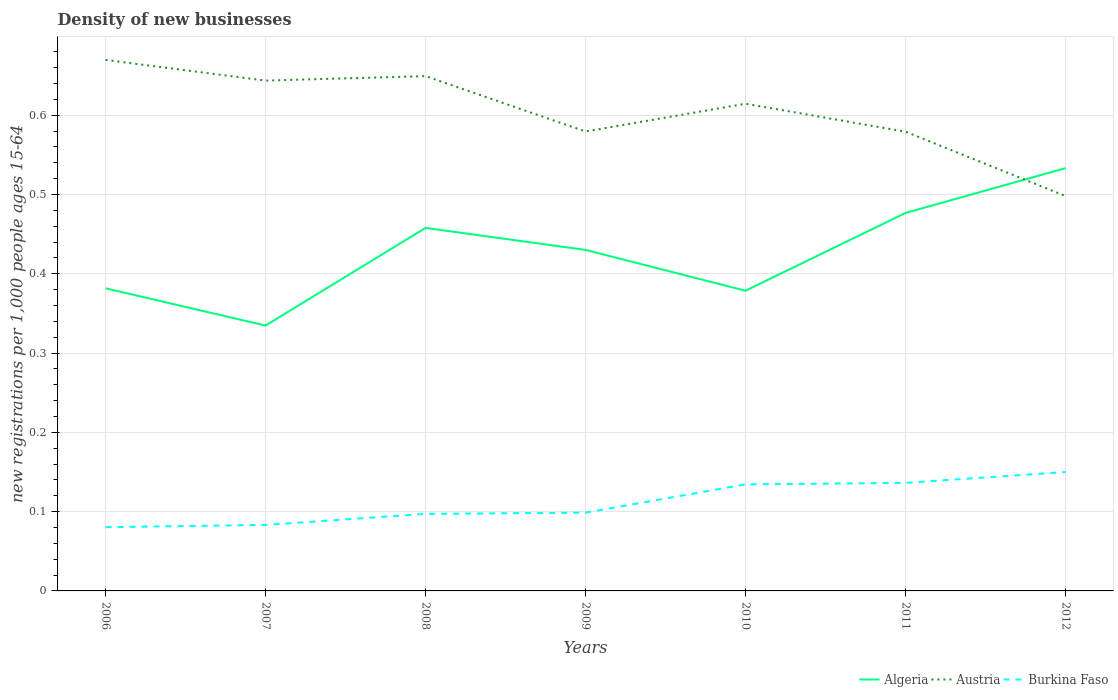Does the line corresponding to Algeria intersect with the line corresponding to Austria?
Your response must be concise. Yes. Is the number of lines equal to the number of legend labels?
Offer a very short reply. Yes. Across all years, what is the maximum number of new registrations in Burkina Faso?
Offer a very short reply. 0.08. In which year was the number of new registrations in Burkina Faso maximum?
Make the answer very short. 2006. What is the total number of new registrations in Austria in the graph?
Give a very brief answer. 0.07. What is the difference between the highest and the second highest number of new registrations in Austria?
Offer a terse response. 0.17. Is the number of new registrations in Burkina Faso strictly greater than the number of new registrations in Algeria over the years?
Your answer should be compact. Yes. Are the values on the major ticks of Y-axis written in scientific E-notation?
Ensure brevity in your answer.  No. Does the graph contain any zero values?
Keep it short and to the point. No. Where does the legend appear in the graph?
Offer a very short reply. Bottom right. How are the legend labels stacked?
Your answer should be compact. Horizontal. What is the title of the graph?
Offer a very short reply. Density of new businesses. Does "Kuwait" appear as one of the legend labels in the graph?
Your answer should be compact. No. What is the label or title of the X-axis?
Give a very brief answer. Years. What is the label or title of the Y-axis?
Keep it short and to the point. New registrations per 1,0 people ages 15-64. What is the new registrations per 1,000 people ages 15-64 in Algeria in 2006?
Your answer should be compact. 0.38. What is the new registrations per 1,000 people ages 15-64 in Austria in 2006?
Offer a very short reply. 0.67. What is the new registrations per 1,000 people ages 15-64 in Burkina Faso in 2006?
Provide a succinct answer. 0.08. What is the new registrations per 1,000 people ages 15-64 of Algeria in 2007?
Ensure brevity in your answer.  0.33. What is the new registrations per 1,000 people ages 15-64 in Austria in 2007?
Your answer should be compact. 0.64. What is the new registrations per 1,000 people ages 15-64 in Burkina Faso in 2007?
Your response must be concise. 0.08. What is the new registrations per 1,000 people ages 15-64 in Algeria in 2008?
Your response must be concise. 0.46. What is the new registrations per 1,000 people ages 15-64 in Austria in 2008?
Keep it short and to the point. 0.65. What is the new registrations per 1,000 people ages 15-64 in Burkina Faso in 2008?
Provide a succinct answer. 0.1. What is the new registrations per 1,000 people ages 15-64 of Algeria in 2009?
Your answer should be very brief. 0.43. What is the new registrations per 1,000 people ages 15-64 of Austria in 2009?
Your answer should be very brief. 0.58. What is the new registrations per 1,000 people ages 15-64 in Burkina Faso in 2009?
Ensure brevity in your answer.  0.1. What is the new registrations per 1,000 people ages 15-64 in Algeria in 2010?
Offer a very short reply. 0.38. What is the new registrations per 1,000 people ages 15-64 of Austria in 2010?
Your response must be concise. 0.61. What is the new registrations per 1,000 people ages 15-64 of Burkina Faso in 2010?
Give a very brief answer. 0.13. What is the new registrations per 1,000 people ages 15-64 in Algeria in 2011?
Offer a very short reply. 0.48. What is the new registrations per 1,000 people ages 15-64 in Austria in 2011?
Make the answer very short. 0.58. What is the new registrations per 1,000 people ages 15-64 in Burkina Faso in 2011?
Your answer should be very brief. 0.14. What is the new registrations per 1,000 people ages 15-64 in Algeria in 2012?
Your answer should be compact. 0.53. What is the new registrations per 1,000 people ages 15-64 in Austria in 2012?
Give a very brief answer. 0.5. What is the new registrations per 1,000 people ages 15-64 of Burkina Faso in 2012?
Your response must be concise. 0.15. Across all years, what is the maximum new registrations per 1,000 people ages 15-64 in Algeria?
Your answer should be very brief. 0.53. Across all years, what is the maximum new registrations per 1,000 people ages 15-64 of Austria?
Offer a very short reply. 0.67. Across all years, what is the maximum new registrations per 1,000 people ages 15-64 in Burkina Faso?
Make the answer very short. 0.15. Across all years, what is the minimum new registrations per 1,000 people ages 15-64 of Algeria?
Offer a very short reply. 0.33. Across all years, what is the minimum new registrations per 1,000 people ages 15-64 in Austria?
Offer a very short reply. 0.5. Across all years, what is the minimum new registrations per 1,000 people ages 15-64 of Burkina Faso?
Ensure brevity in your answer.  0.08. What is the total new registrations per 1,000 people ages 15-64 of Algeria in the graph?
Ensure brevity in your answer.  2.99. What is the total new registrations per 1,000 people ages 15-64 in Austria in the graph?
Provide a succinct answer. 4.23. What is the total new registrations per 1,000 people ages 15-64 of Burkina Faso in the graph?
Offer a terse response. 0.78. What is the difference between the new registrations per 1,000 people ages 15-64 of Algeria in 2006 and that in 2007?
Offer a terse response. 0.05. What is the difference between the new registrations per 1,000 people ages 15-64 in Austria in 2006 and that in 2007?
Provide a short and direct response. 0.03. What is the difference between the new registrations per 1,000 people ages 15-64 in Burkina Faso in 2006 and that in 2007?
Offer a very short reply. -0. What is the difference between the new registrations per 1,000 people ages 15-64 in Algeria in 2006 and that in 2008?
Offer a terse response. -0.08. What is the difference between the new registrations per 1,000 people ages 15-64 of Austria in 2006 and that in 2008?
Give a very brief answer. 0.02. What is the difference between the new registrations per 1,000 people ages 15-64 in Burkina Faso in 2006 and that in 2008?
Ensure brevity in your answer.  -0.02. What is the difference between the new registrations per 1,000 people ages 15-64 of Algeria in 2006 and that in 2009?
Your answer should be very brief. -0.05. What is the difference between the new registrations per 1,000 people ages 15-64 of Austria in 2006 and that in 2009?
Make the answer very short. 0.09. What is the difference between the new registrations per 1,000 people ages 15-64 in Burkina Faso in 2006 and that in 2009?
Keep it short and to the point. -0.02. What is the difference between the new registrations per 1,000 people ages 15-64 of Algeria in 2006 and that in 2010?
Provide a short and direct response. 0. What is the difference between the new registrations per 1,000 people ages 15-64 of Austria in 2006 and that in 2010?
Your answer should be compact. 0.06. What is the difference between the new registrations per 1,000 people ages 15-64 of Burkina Faso in 2006 and that in 2010?
Provide a succinct answer. -0.05. What is the difference between the new registrations per 1,000 people ages 15-64 of Algeria in 2006 and that in 2011?
Give a very brief answer. -0.1. What is the difference between the new registrations per 1,000 people ages 15-64 in Austria in 2006 and that in 2011?
Make the answer very short. 0.09. What is the difference between the new registrations per 1,000 people ages 15-64 of Burkina Faso in 2006 and that in 2011?
Offer a very short reply. -0.06. What is the difference between the new registrations per 1,000 people ages 15-64 in Algeria in 2006 and that in 2012?
Ensure brevity in your answer.  -0.15. What is the difference between the new registrations per 1,000 people ages 15-64 of Austria in 2006 and that in 2012?
Provide a short and direct response. 0.17. What is the difference between the new registrations per 1,000 people ages 15-64 in Burkina Faso in 2006 and that in 2012?
Ensure brevity in your answer.  -0.07. What is the difference between the new registrations per 1,000 people ages 15-64 in Algeria in 2007 and that in 2008?
Your answer should be compact. -0.12. What is the difference between the new registrations per 1,000 people ages 15-64 of Austria in 2007 and that in 2008?
Your answer should be very brief. -0.01. What is the difference between the new registrations per 1,000 people ages 15-64 of Burkina Faso in 2007 and that in 2008?
Keep it short and to the point. -0.01. What is the difference between the new registrations per 1,000 people ages 15-64 in Algeria in 2007 and that in 2009?
Make the answer very short. -0.1. What is the difference between the new registrations per 1,000 people ages 15-64 in Austria in 2007 and that in 2009?
Offer a terse response. 0.06. What is the difference between the new registrations per 1,000 people ages 15-64 in Burkina Faso in 2007 and that in 2009?
Your answer should be compact. -0.02. What is the difference between the new registrations per 1,000 people ages 15-64 in Algeria in 2007 and that in 2010?
Ensure brevity in your answer.  -0.04. What is the difference between the new registrations per 1,000 people ages 15-64 in Austria in 2007 and that in 2010?
Your response must be concise. 0.03. What is the difference between the new registrations per 1,000 people ages 15-64 of Burkina Faso in 2007 and that in 2010?
Your answer should be compact. -0.05. What is the difference between the new registrations per 1,000 people ages 15-64 in Algeria in 2007 and that in 2011?
Keep it short and to the point. -0.14. What is the difference between the new registrations per 1,000 people ages 15-64 of Austria in 2007 and that in 2011?
Your answer should be compact. 0.06. What is the difference between the new registrations per 1,000 people ages 15-64 in Burkina Faso in 2007 and that in 2011?
Make the answer very short. -0.05. What is the difference between the new registrations per 1,000 people ages 15-64 of Algeria in 2007 and that in 2012?
Give a very brief answer. -0.2. What is the difference between the new registrations per 1,000 people ages 15-64 in Austria in 2007 and that in 2012?
Your answer should be compact. 0.15. What is the difference between the new registrations per 1,000 people ages 15-64 of Burkina Faso in 2007 and that in 2012?
Offer a terse response. -0.07. What is the difference between the new registrations per 1,000 people ages 15-64 in Algeria in 2008 and that in 2009?
Offer a terse response. 0.03. What is the difference between the new registrations per 1,000 people ages 15-64 in Austria in 2008 and that in 2009?
Keep it short and to the point. 0.07. What is the difference between the new registrations per 1,000 people ages 15-64 in Burkina Faso in 2008 and that in 2009?
Give a very brief answer. -0. What is the difference between the new registrations per 1,000 people ages 15-64 of Algeria in 2008 and that in 2010?
Your response must be concise. 0.08. What is the difference between the new registrations per 1,000 people ages 15-64 of Austria in 2008 and that in 2010?
Provide a succinct answer. 0.03. What is the difference between the new registrations per 1,000 people ages 15-64 in Burkina Faso in 2008 and that in 2010?
Provide a short and direct response. -0.04. What is the difference between the new registrations per 1,000 people ages 15-64 of Algeria in 2008 and that in 2011?
Your answer should be compact. -0.02. What is the difference between the new registrations per 1,000 people ages 15-64 of Austria in 2008 and that in 2011?
Provide a short and direct response. 0.07. What is the difference between the new registrations per 1,000 people ages 15-64 of Burkina Faso in 2008 and that in 2011?
Ensure brevity in your answer.  -0.04. What is the difference between the new registrations per 1,000 people ages 15-64 in Algeria in 2008 and that in 2012?
Your answer should be very brief. -0.08. What is the difference between the new registrations per 1,000 people ages 15-64 of Austria in 2008 and that in 2012?
Give a very brief answer. 0.15. What is the difference between the new registrations per 1,000 people ages 15-64 of Burkina Faso in 2008 and that in 2012?
Provide a short and direct response. -0.05. What is the difference between the new registrations per 1,000 people ages 15-64 in Algeria in 2009 and that in 2010?
Provide a short and direct response. 0.05. What is the difference between the new registrations per 1,000 people ages 15-64 in Austria in 2009 and that in 2010?
Your response must be concise. -0.04. What is the difference between the new registrations per 1,000 people ages 15-64 in Burkina Faso in 2009 and that in 2010?
Your answer should be very brief. -0.04. What is the difference between the new registrations per 1,000 people ages 15-64 in Algeria in 2009 and that in 2011?
Your answer should be very brief. -0.05. What is the difference between the new registrations per 1,000 people ages 15-64 in Burkina Faso in 2009 and that in 2011?
Your response must be concise. -0.04. What is the difference between the new registrations per 1,000 people ages 15-64 in Algeria in 2009 and that in 2012?
Your answer should be compact. -0.1. What is the difference between the new registrations per 1,000 people ages 15-64 of Austria in 2009 and that in 2012?
Your response must be concise. 0.08. What is the difference between the new registrations per 1,000 people ages 15-64 of Burkina Faso in 2009 and that in 2012?
Offer a terse response. -0.05. What is the difference between the new registrations per 1,000 people ages 15-64 in Algeria in 2010 and that in 2011?
Provide a short and direct response. -0.1. What is the difference between the new registrations per 1,000 people ages 15-64 in Austria in 2010 and that in 2011?
Offer a very short reply. 0.04. What is the difference between the new registrations per 1,000 people ages 15-64 of Burkina Faso in 2010 and that in 2011?
Provide a short and direct response. -0. What is the difference between the new registrations per 1,000 people ages 15-64 in Algeria in 2010 and that in 2012?
Offer a very short reply. -0.15. What is the difference between the new registrations per 1,000 people ages 15-64 in Austria in 2010 and that in 2012?
Keep it short and to the point. 0.12. What is the difference between the new registrations per 1,000 people ages 15-64 in Burkina Faso in 2010 and that in 2012?
Provide a short and direct response. -0.02. What is the difference between the new registrations per 1,000 people ages 15-64 in Algeria in 2011 and that in 2012?
Make the answer very short. -0.06. What is the difference between the new registrations per 1,000 people ages 15-64 of Austria in 2011 and that in 2012?
Your answer should be compact. 0.08. What is the difference between the new registrations per 1,000 people ages 15-64 in Burkina Faso in 2011 and that in 2012?
Provide a succinct answer. -0.01. What is the difference between the new registrations per 1,000 people ages 15-64 of Algeria in 2006 and the new registrations per 1,000 people ages 15-64 of Austria in 2007?
Provide a short and direct response. -0.26. What is the difference between the new registrations per 1,000 people ages 15-64 in Algeria in 2006 and the new registrations per 1,000 people ages 15-64 in Burkina Faso in 2007?
Your answer should be compact. 0.3. What is the difference between the new registrations per 1,000 people ages 15-64 in Austria in 2006 and the new registrations per 1,000 people ages 15-64 in Burkina Faso in 2007?
Ensure brevity in your answer.  0.59. What is the difference between the new registrations per 1,000 people ages 15-64 of Algeria in 2006 and the new registrations per 1,000 people ages 15-64 of Austria in 2008?
Provide a succinct answer. -0.27. What is the difference between the new registrations per 1,000 people ages 15-64 in Algeria in 2006 and the new registrations per 1,000 people ages 15-64 in Burkina Faso in 2008?
Ensure brevity in your answer.  0.28. What is the difference between the new registrations per 1,000 people ages 15-64 in Austria in 2006 and the new registrations per 1,000 people ages 15-64 in Burkina Faso in 2008?
Offer a terse response. 0.57. What is the difference between the new registrations per 1,000 people ages 15-64 of Algeria in 2006 and the new registrations per 1,000 people ages 15-64 of Austria in 2009?
Ensure brevity in your answer.  -0.2. What is the difference between the new registrations per 1,000 people ages 15-64 in Algeria in 2006 and the new registrations per 1,000 people ages 15-64 in Burkina Faso in 2009?
Give a very brief answer. 0.28. What is the difference between the new registrations per 1,000 people ages 15-64 of Austria in 2006 and the new registrations per 1,000 people ages 15-64 of Burkina Faso in 2009?
Provide a short and direct response. 0.57. What is the difference between the new registrations per 1,000 people ages 15-64 of Algeria in 2006 and the new registrations per 1,000 people ages 15-64 of Austria in 2010?
Make the answer very short. -0.23. What is the difference between the new registrations per 1,000 people ages 15-64 of Algeria in 2006 and the new registrations per 1,000 people ages 15-64 of Burkina Faso in 2010?
Provide a short and direct response. 0.25. What is the difference between the new registrations per 1,000 people ages 15-64 in Austria in 2006 and the new registrations per 1,000 people ages 15-64 in Burkina Faso in 2010?
Give a very brief answer. 0.54. What is the difference between the new registrations per 1,000 people ages 15-64 in Algeria in 2006 and the new registrations per 1,000 people ages 15-64 in Austria in 2011?
Provide a succinct answer. -0.2. What is the difference between the new registrations per 1,000 people ages 15-64 of Algeria in 2006 and the new registrations per 1,000 people ages 15-64 of Burkina Faso in 2011?
Provide a short and direct response. 0.25. What is the difference between the new registrations per 1,000 people ages 15-64 in Austria in 2006 and the new registrations per 1,000 people ages 15-64 in Burkina Faso in 2011?
Provide a succinct answer. 0.53. What is the difference between the new registrations per 1,000 people ages 15-64 of Algeria in 2006 and the new registrations per 1,000 people ages 15-64 of Austria in 2012?
Give a very brief answer. -0.12. What is the difference between the new registrations per 1,000 people ages 15-64 in Algeria in 2006 and the new registrations per 1,000 people ages 15-64 in Burkina Faso in 2012?
Make the answer very short. 0.23. What is the difference between the new registrations per 1,000 people ages 15-64 in Austria in 2006 and the new registrations per 1,000 people ages 15-64 in Burkina Faso in 2012?
Provide a short and direct response. 0.52. What is the difference between the new registrations per 1,000 people ages 15-64 in Algeria in 2007 and the new registrations per 1,000 people ages 15-64 in Austria in 2008?
Offer a terse response. -0.31. What is the difference between the new registrations per 1,000 people ages 15-64 in Algeria in 2007 and the new registrations per 1,000 people ages 15-64 in Burkina Faso in 2008?
Keep it short and to the point. 0.24. What is the difference between the new registrations per 1,000 people ages 15-64 of Austria in 2007 and the new registrations per 1,000 people ages 15-64 of Burkina Faso in 2008?
Your answer should be very brief. 0.55. What is the difference between the new registrations per 1,000 people ages 15-64 in Algeria in 2007 and the new registrations per 1,000 people ages 15-64 in Austria in 2009?
Your response must be concise. -0.24. What is the difference between the new registrations per 1,000 people ages 15-64 of Algeria in 2007 and the new registrations per 1,000 people ages 15-64 of Burkina Faso in 2009?
Offer a terse response. 0.24. What is the difference between the new registrations per 1,000 people ages 15-64 of Austria in 2007 and the new registrations per 1,000 people ages 15-64 of Burkina Faso in 2009?
Provide a short and direct response. 0.54. What is the difference between the new registrations per 1,000 people ages 15-64 in Algeria in 2007 and the new registrations per 1,000 people ages 15-64 in Austria in 2010?
Provide a short and direct response. -0.28. What is the difference between the new registrations per 1,000 people ages 15-64 in Algeria in 2007 and the new registrations per 1,000 people ages 15-64 in Burkina Faso in 2010?
Keep it short and to the point. 0.2. What is the difference between the new registrations per 1,000 people ages 15-64 of Austria in 2007 and the new registrations per 1,000 people ages 15-64 of Burkina Faso in 2010?
Provide a short and direct response. 0.51. What is the difference between the new registrations per 1,000 people ages 15-64 in Algeria in 2007 and the new registrations per 1,000 people ages 15-64 in Austria in 2011?
Ensure brevity in your answer.  -0.24. What is the difference between the new registrations per 1,000 people ages 15-64 in Algeria in 2007 and the new registrations per 1,000 people ages 15-64 in Burkina Faso in 2011?
Keep it short and to the point. 0.2. What is the difference between the new registrations per 1,000 people ages 15-64 in Austria in 2007 and the new registrations per 1,000 people ages 15-64 in Burkina Faso in 2011?
Provide a succinct answer. 0.51. What is the difference between the new registrations per 1,000 people ages 15-64 of Algeria in 2007 and the new registrations per 1,000 people ages 15-64 of Austria in 2012?
Keep it short and to the point. -0.16. What is the difference between the new registrations per 1,000 people ages 15-64 of Algeria in 2007 and the new registrations per 1,000 people ages 15-64 of Burkina Faso in 2012?
Keep it short and to the point. 0.18. What is the difference between the new registrations per 1,000 people ages 15-64 in Austria in 2007 and the new registrations per 1,000 people ages 15-64 in Burkina Faso in 2012?
Your response must be concise. 0.49. What is the difference between the new registrations per 1,000 people ages 15-64 in Algeria in 2008 and the new registrations per 1,000 people ages 15-64 in Austria in 2009?
Make the answer very short. -0.12. What is the difference between the new registrations per 1,000 people ages 15-64 in Algeria in 2008 and the new registrations per 1,000 people ages 15-64 in Burkina Faso in 2009?
Provide a succinct answer. 0.36. What is the difference between the new registrations per 1,000 people ages 15-64 in Austria in 2008 and the new registrations per 1,000 people ages 15-64 in Burkina Faso in 2009?
Provide a short and direct response. 0.55. What is the difference between the new registrations per 1,000 people ages 15-64 in Algeria in 2008 and the new registrations per 1,000 people ages 15-64 in Austria in 2010?
Ensure brevity in your answer.  -0.16. What is the difference between the new registrations per 1,000 people ages 15-64 in Algeria in 2008 and the new registrations per 1,000 people ages 15-64 in Burkina Faso in 2010?
Your answer should be compact. 0.32. What is the difference between the new registrations per 1,000 people ages 15-64 in Austria in 2008 and the new registrations per 1,000 people ages 15-64 in Burkina Faso in 2010?
Ensure brevity in your answer.  0.52. What is the difference between the new registrations per 1,000 people ages 15-64 of Algeria in 2008 and the new registrations per 1,000 people ages 15-64 of Austria in 2011?
Make the answer very short. -0.12. What is the difference between the new registrations per 1,000 people ages 15-64 in Algeria in 2008 and the new registrations per 1,000 people ages 15-64 in Burkina Faso in 2011?
Ensure brevity in your answer.  0.32. What is the difference between the new registrations per 1,000 people ages 15-64 of Austria in 2008 and the new registrations per 1,000 people ages 15-64 of Burkina Faso in 2011?
Your answer should be very brief. 0.51. What is the difference between the new registrations per 1,000 people ages 15-64 of Algeria in 2008 and the new registrations per 1,000 people ages 15-64 of Austria in 2012?
Ensure brevity in your answer.  -0.04. What is the difference between the new registrations per 1,000 people ages 15-64 of Algeria in 2008 and the new registrations per 1,000 people ages 15-64 of Burkina Faso in 2012?
Offer a terse response. 0.31. What is the difference between the new registrations per 1,000 people ages 15-64 of Austria in 2008 and the new registrations per 1,000 people ages 15-64 of Burkina Faso in 2012?
Your answer should be compact. 0.5. What is the difference between the new registrations per 1,000 people ages 15-64 in Algeria in 2009 and the new registrations per 1,000 people ages 15-64 in Austria in 2010?
Ensure brevity in your answer.  -0.18. What is the difference between the new registrations per 1,000 people ages 15-64 in Algeria in 2009 and the new registrations per 1,000 people ages 15-64 in Burkina Faso in 2010?
Offer a terse response. 0.3. What is the difference between the new registrations per 1,000 people ages 15-64 in Austria in 2009 and the new registrations per 1,000 people ages 15-64 in Burkina Faso in 2010?
Your answer should be very brief. 0.45. What is the difference between the new registrations per 1,000 people ages 15-64 of Algeria in 2009 and the new registrations per 1,000 people ages 15-64 of Austria in 2011?
Your response must be concise. -0.15. What is the difference between the new registrations per 1,000 people ages 15-64 in Algeria in 2009 and the new registrations per 1,000 people ages 15-64 in Burkina Faso in 2011?
Your answer should be compact. 0.29. What is the difference between the new registrations per 1,000 people ages 15-64 in Austria in 2009 and the new registrations per 1,000 people ages 15-64 in Burkina Faso in 2011?
Provide a succinct answer. 0.44. What is the difference between the new registrations per 1,000 people ages 15-64 in Algeria in 2009 and the new registrations per 1,000 people ages 15-64 in Austria in 2012?
Your answer should be very brief. -0.07. What is the difference between the new registrations per 1,000 people ages 15-64 in Algeria in 2009 and the new registrations per 1,000 people ages 15-64 in Burkina Faso in 2012?
Give a very brief answer. 0.28. What is the difference between the new registrations per 1,000 people ages 15-64 of Austria in 2009 and the new registrations per 1,000 people ages 15-64 of Burkina Faso in 2012?
Your response must be concise. 0.43. What is the difference between the new registrations per 1,000 people ages 15-64 in Algeria in 2010 and the new registrations per 1,000 people ages 15-64 in Austria in 2011?
Offer a terse response. -0.2. What is the difference between the new registrations per 1,000 people ages 15-64 of Algeria in 2010 and the new registrations per 1,000 people ages 15-64 of Burkina Faso in 2011?
Offer a terse response. 0.24. What is the difference between the new registrations per 1,000 people ages 15-64 of Austria in 2010 and the new registrations per 1,000 people ages 15-64 of Burkina Faso in 2011?
Your answer should be compact. 0.48. What is the difference between the new registrations per 1,000 people ages 15-64 of Algeria in 2010 and the new registrations per 1,000 people ages 15-64 of Austria in 2012?
Ensure brevity in your answer.  -0.12. What is the difference between the new registrations per 1,000 people ages 15-64 in Algeria in 2010 and the new registrations per 1,000 people ages 15-64 in Burkina Faso in 2012?
Your answer should be very brief. 0.23. What is the difference between the new registrations per 1,000 people ages 15-64 of Austria in 2010 and the new registrations per 1,000 people ages 15-64 of Burkina Faso in 2012?
Your answer should be compact. 0.46. What is the difference between the new registrations per 1,000 people ages 15-64 in Algeria in 2011 and the new registrations per 1,000 people ages 15-64 in Austria in 2012?
Keep it short and to the point. -0.02. What is the difference between the new registrations per 1,000 people ages 15-64 of Algeria in 2011 and the new registrations per 1,000 people ages 15-64 of Burkina Faso in 2012?
Provide a short and direct response. 0.33. What is the difference between the new registrations per 1,000 people ages 15-64 in Austria in 2011 and the new registrations per 1,000 people ages 15-64 in Burkina Faso in 2012?
Offer a very short reply. 0.43. What is the average new registrations per 1,000 people ages 15-64 of Algeria per year?
Provide a succinct answer. 0.43. What is the average new registrations per 1,000 people ages 15-64 of Austria per year?
Your answer should be very brief. 0.6. What is the average new registrations per 1,000 people ages 15-64 of Burkina Faso per year?
Give a very brief answer. 0.11. In the year 2006, what is the difference between the new registrations per 1,000 people ages 15-64 of Algeria and new registrations per 1,000 people ages 15-64 of Austria?
Keep it short and to the point. -0.29. In the year 2006, what is the difference between the new registrations per 1,000 people ages 15-64 of Algeria and new registrations per 1,000 people ages 15-64 of Burkina Faso?
Provide a succinct answer. 0.3. In the year 2006, what is the difference between the new registrations per 1,000 people ages 15-64 of Austria and new registrations per 1,000 people ages 15-64 of Burkina Faso?
Ensure brevity in your answer.  0.59. In the year 2007, what is the difference between the new registrations per 1,000 people ages 15-64 in Algeria and new registrations per 1,000 people ages 15-64 in Austria?
Ensure brevity in your answer.  -0.31. In the year 2007, what is the difference between the new registrations per 1,000 people ages 15-64 of Algeria and new registrations per 1,000 people ages 15-64 of Burkina Faso?
Provide a short and direct response. 0.25. In the year 2007, what is the difference between the new registrations per 1,000 people ages 15-64 of Austria and new registrations per 1,000 people ages 15-64 of Burkina Faso?
Your answer should be compact. 0.56. In the year 2008, what is the difference between the new registrations per 1,000 people ages 15-64 in Algeria and new registrations per 1,000 people ages 15-64 in Austria?
Offer a terse response. -0.19. In the year 2008, what is the difference between the new registrations per 1,000 people ages 15-64 in Algeria and new registrations per 1,000 people ages 15-64 in Burkina Faso?
Ensure brevity in your answer.  0.36. In the year 2008, what is the difference between the new registrations per 1,000 people ages 15-64 of Austria and new registrations per 1,000 people ages 15-64 of Burkina Faso?
Ensure brevity in your answer.  0.55. In the year 2009, what is the difference between the new registrations per 1,000 people ages 15-64 of Algeria and new registrations per 1,000 people ages 15-64 of Austria?
Offer a very short reply. -0.15. In the year 2009, what is the difference between the new registrations per 1,000 people ages 15-64 in Algeria and new registrations per 1,000 people ages 15-64 in Burkina Faso?
Your answer should be very brief. 0.33. In the year 2009, what is the difference between the new registrations per 1,000 people ages 15-64 of Austria and new registrations per 1,000 people ages 15-64 of Burkina Faso?
Give a very brief answer. 0.48. In the year 2010, what is the difference between the new registrations per 1,000 people ages 15-64 of Algeria and new registrations per 1,000 people ages 15-64 of Austria?
Offer a terse response. -0.24. In the year 2010, what is the difference between the new registrations per 1,000 people ages 15-64 of Algeria and new registrations per 1,000 people ages 15-64 of Burkina Faso?
Make the answer very short. 0.24. In the year 2010, what is the difference between the new registrations per 1,000 people ages 15-64 of Austria and new registrations per 1,000 people ages 15-64 of Burkina Faso?
Your response must be concise. 0.48. In the year 2011, what is the difference between the new registrations per 1,000 people ages 15-64 in Algeria and new registrations per 1,000 people ages 15-64 in Austria?
Your response must be concise. -0.1. In the year 2011, what is the difference between the new registrations per 1,000 people ages 15-64 of Algeria and new registrations per 1,000 people ages 15-64 of Burkina Faso?
Your answer should be compact. 0.34. In the year 2011, what is the difference between the new registrations per 1,000 people ages 15-64 of Austria and new registrations per 1,000 people ages 15-64 of Burkina Faso?
Keep it short and to the point. 0.44. In the year 2012, what is the difference between the new registrations per 1,000 people ages 15-64 of Algeria and new registrations per 1,000 people ages 15-64 of Austria?
Give a very brief answer. 0.04. In the year 2012, what is the difference between the new registrations per 1,000 people ages 15-64 in Algeria and new registrations per 1,000 people ages 15-64 in Burkina Faso?
Provide a short and direct response. 0.38. In the year 2012, what is the difference between the new registrations per 1,000 people ages 15-64 in Austria and new registrations per 1,000 people ages 15-64 in Burkina Faso?
Keep it short and to the point. 0.35. What is the ratio of the new registrations per 1,000 people ages 15-64 of Algeria in 2006 to that in 2007?
Ensure brevity in your answer.  1.14. What is the ratio of the new registrations per 1,000 people ages 15-64 of Austria in 2006 to that in 2007?
Provide a succinct answer. 1.04. What is the ratio of the new registrations per 1,000 people ages 15-64 in Burkina Faso in 2006 to that in 2007?
Your answer should be very brief. 0.97. What is the ratio of the new registrations per 1,000 people ages 15-64 of Algeria in 2006 to that in 2008?
Your response must be concise. 0.83. What is the ratio of the new registrations per 1,000 people ages 15-64 of Austria in 2006 to that in 2008?
Provide a short and direct response. 1.03. What is the ratio of the new registrations per 1,000 people ages 15-64 of Burkina Faso in 2006 to that in 2008?
Provide a short and direct response. 0.83. What is the ratio of the new registrations per 1,000 people ages 15-64 in Algeria in 2006 to that in 2009?
Keep it short and to the point. 0.89. What is the ratio of the new registrations per 1,000 people ages 15-64 of Austria in 2006 to that in 2009?
Make the answer very short. 1.16. What is the ratio of the new registrations per 1,000 people ages 15-64 in Burkina Faso in 2006 to that in 2009?
Ensure brevity in your answer.  0.81. What is the ratio of the new registrations per 1,000 people ages 15-64 in Austria in 2006 to that in 2010?
Your response must be concise. 1.09. What is the ratio of the new registrations per 1,000 people ages 15-64 in Burkina Faso in 2006 to that in 2010?
Keep it short and to the point. 0.6. What is the ratio of the new registrations per 1,000 people ages 15-64 of Algeria in 2006 to that in 2011?
Make the answer very short. 0.8. What is the ratio of the new registrations per 1,000 people ages 15-64 of Austria in 2006 to that in 2011?
Provide a succinct answer. 1.16. What is the ratio of the new registrations per 1,000 people ages 15-64 in Burkina Faso in 2006 to that in 2011?
Provide a succinct answer. 0.59. What is the ratio of the new registrations per 1,000 people ages 15-64 in Algeria in 2006 to that in 2012?
Ensure brevity in your answer.  0.72. What is the ratio of the new registrations per 1,000 people ages 15-64 in Austria in 2006 to that in 2012?
Make the answer very short. 1.34. What is the ratio of the new registrations per 1,000 people ages 15-64 of Burkina Faso in 2006 to that in 2012?
Provide a succinct answer. 0.54. What is the ratio of the new registrations per 1,000 people ages 15-64 of Algeria in 2007 to that in 2008?
Your answer should be compact. 0.73. What is the ratio of the new registrations per 1,000 people ages 15-64 of Austria in 2007 to that in 2008?
Provide a short and direct response. 0.99. What is the ratio of the new registrations per 1,000 people ages 15-64 of Burkina Faso in 2007 to that in 2008?
Offer a very short reply. 0.86. What is the ratio of the new registrations per 1,000 people ages 15-64 of Algeria in 2007 to that in 2009?
Ensure brevity in your answer.  0.78. What is the ratio of the new registrations per 1,000 people ages 15-64 in Austria in 2007 to that in 2009?
Provide a short and direct response. 1.11. What is the ratio of the new registrations per 1,000 people ages 15-64 of Burkina Faso in 2007 to that in 2009?
Make the answer very short. 0.84. What is the ratio of the new registrations per 1,000 people ages 15-64 of Algeria in 2007 to that in 2010?
Provide a succinct answer. 0.88. What is the ratio of the new registrations per 1,000 people ages 15-64 in Austria in 2007 to that in 2010?
Provide a short and direct response. 1.05. What is the ratio of the new registrations per 1,000 people ages 15-64 of Burkina Faso in 2007 to that in 2010?
Your answer should be compact. 0.62. What is the ratio of the new registrations per 1,000 people ages 15-64 in Algeria in 2007 to that in 2011?
Keep it short and to the point. 0.7. What is the ratio of the new registrations per 1,000 people ages 15-64 in Austria in 2007 to that in 2011?
Give a very brief answer. 1.11. What is the ratio of the new registrations per 1,000 people ages 15-64 of Burkina Faso in 2007 to that in 2011?
Keep it short and to the point. 0.61. What is the ratio of the new registrations per 1,000 people ages 15-64 of Algeria in 2007 to that in 2012?
Your answer should be compact. 0.63. What is the ratio of the new registrations per 1,000 people ages 15-64 of Austria in 2007 to that in 2012?
Provide a succinct answer. 1.29. What is the ratio of the new registrations per 1,000 people ages 15-64 of Burkina Faso in 2007 to that in 2012?
Offer a terse response. 0.56. What is the ratio of the new registrations per 1,000 people ages 15-64 in Algeria in 2008 to that in 2009?
Your answer should be compact. 1.06. What is the ratio of the new registrations per 1,000 people ages 15-64 of Austria in 2008 to that in 2009?
Ensure brevity in your answer.  1.12. What is the ratio of the new registrations per 1,000 people ages 15-64 in Burkina Faso in 2008 to that in 2009?
Your answer should be very brief. 0.98. What is the ratio of the new registrations per 1,000 people ages 15-64 of Algeria in 2008 to that in 2010?
Your answer should be very brief. 1.21. What is the ratio of the new registrations per 1,000 people ages 15-64 of Austria in 2008 to that in 2010?
Keep it short and to the point. 1.06. What is the ratio of the new registrations per 1,000 people ages 15-64 in Burkina Faso in 2008 to that in 2010?
Your answer should be very brief. 0.72. What is the ratio of the new registrations per 1,000 people ages 15-64 in Algeria in 2008 to that in 2011?
Your answer should be compact. 0.96. What is the ratio of the new registrations per 1,000 people ages 15-64 of Austria in 2008 to that in 2011?
Offer a very short reply. 1.12. What is the ratio of the new registrations per 1,000 people ages 15-64 of Burkina Faso in 2008 to that in 2011?
Provide a succinct answer. 0.71. What is the ratio of the new registrations per 1,000 people ages 15-64 of Algeria in 2008 to that in 2012?
Ensure brevity in your answer.  0.86. What is the ratio of the new registrations per 1,000 people ages 15-64 in Austria in 2008 to that in 2012?
Your answer should be compact. 1.3. What is the ratio of the new registrations per 1,000 people ages 15-64 of Burkina Faso in 2008 to that in 2012?
Provide a succinct answer. 0.65. What is the ratio of the new registrations per 1,000 people ages 15-64 in Algeria in 2009 to that in 2010?
Provide a succinct answer. 1.14. What is the ratio of the new registrations per 1,000 people ages 15-64 of Austria in 2009 to that in 2010?
Offer a very short reply. 0.94. What is the ratio of the new registrations per 1,000 people ages 15-64 of Burkina Faso in 2009 to that in 2010?
Give a very brief answer. 0.73. What is the ratio of the new registrations per 1,000 people ages 15-64 of Algeria in 2009 to that in 2011?
Offer a very short reply. 0.9. What is the ratio of the new registrations per 1,000 people ages 15-64 of Austria in 2009 to that in 2011?
Provide a short and direct response. 1. What is the ratio of the new registrations per 1,000 people ages 15-64 in Burkina Faso in 2009 to that in 2011?
Give a very brief answer. 0.72. What is the ratio of the new registrations per 1,000 people ages 15-64 of Algeria in 2009 to that in 2012?
Ensure brevity in your answer.  0.81. What is the ratio of the new registrations per 1,000 people ages 15-64 in Austria in 2009 to that in 2012?
Your response must be concise. 1.16. What is the ratio of the new registrations per 1,000 people ages 15-64 in Burkina Faso in 2009 to that in 2012?
Give a very brief answer. 0.66. What is the ratio of the new registrations per 1,000 people ages 15-64 of Algeria in 2010 to that in 2011?
Provide a succinct answer. 0.79. What is the ratio of the new registrations per 1,000 people ages 15-64 in Austria in 2010 to that in 2011?
Keep it short and to the point. 1.06. What is the ratio of the new registrations per 1,000 people ages 15-64 of Algeria in 2010 to that in 2012?
Ensure brevity in your answer.  0.71. What is the ratio of the new registrations per 1,000 people ages 15-64 in Austria in 2010 to that in 2012?
Your response must be concise. 1.23. What is the ratio of the new registrations per 1,000 people ages 15-64 of Burkina Faso in 2010 to that in 2012?
Give a very brief answer. 0.9. What is the ratio of the new registrations per 1,000 people ages 15-64 of Algeria in 2011 to that in 2012?
Offer a terse response. 0.89. What is the ratio of the new registrations per 1,000 people ages 15-64 in Austria in 2011 to that in 2012?
Provide a succinct answer. 1.16. What is the ratio of the new registrations per 1,000 people ages 15-64 in Burkina Faso in 2011 to that in 2012?
Ensure brevity in your answer.  0.91. What is the difference between the highest and the second highest new registrations per 1,000 people ages 15-64 of Algeria?
Offer a terse response. 0.06. What is the difference between the highest and the second highest new registrations per 1,000 people ages 15-64 in Austria?
Offer a terse response. 0.02. What is the difference between the highest and the second highest new registrations per 1,000 people ages 15-64 in Burkina Faso?
Give a very brief answer. 0.01. What is the difference between the highest and the lowest new registrations per 1,000 people ages 15-64 in Algeria?
Provide a succinct answer. 0.2. What is the difference between the highest and the lowest new registrations per 1,000 people ages 15-64 of Austria?
Provide a succinct answer. 0.17. What is the difference between the highest and the lowest new registrations per 1,000 people ages 15-64 in Burkina Faso?
Give a very brief answer. 0.07. 